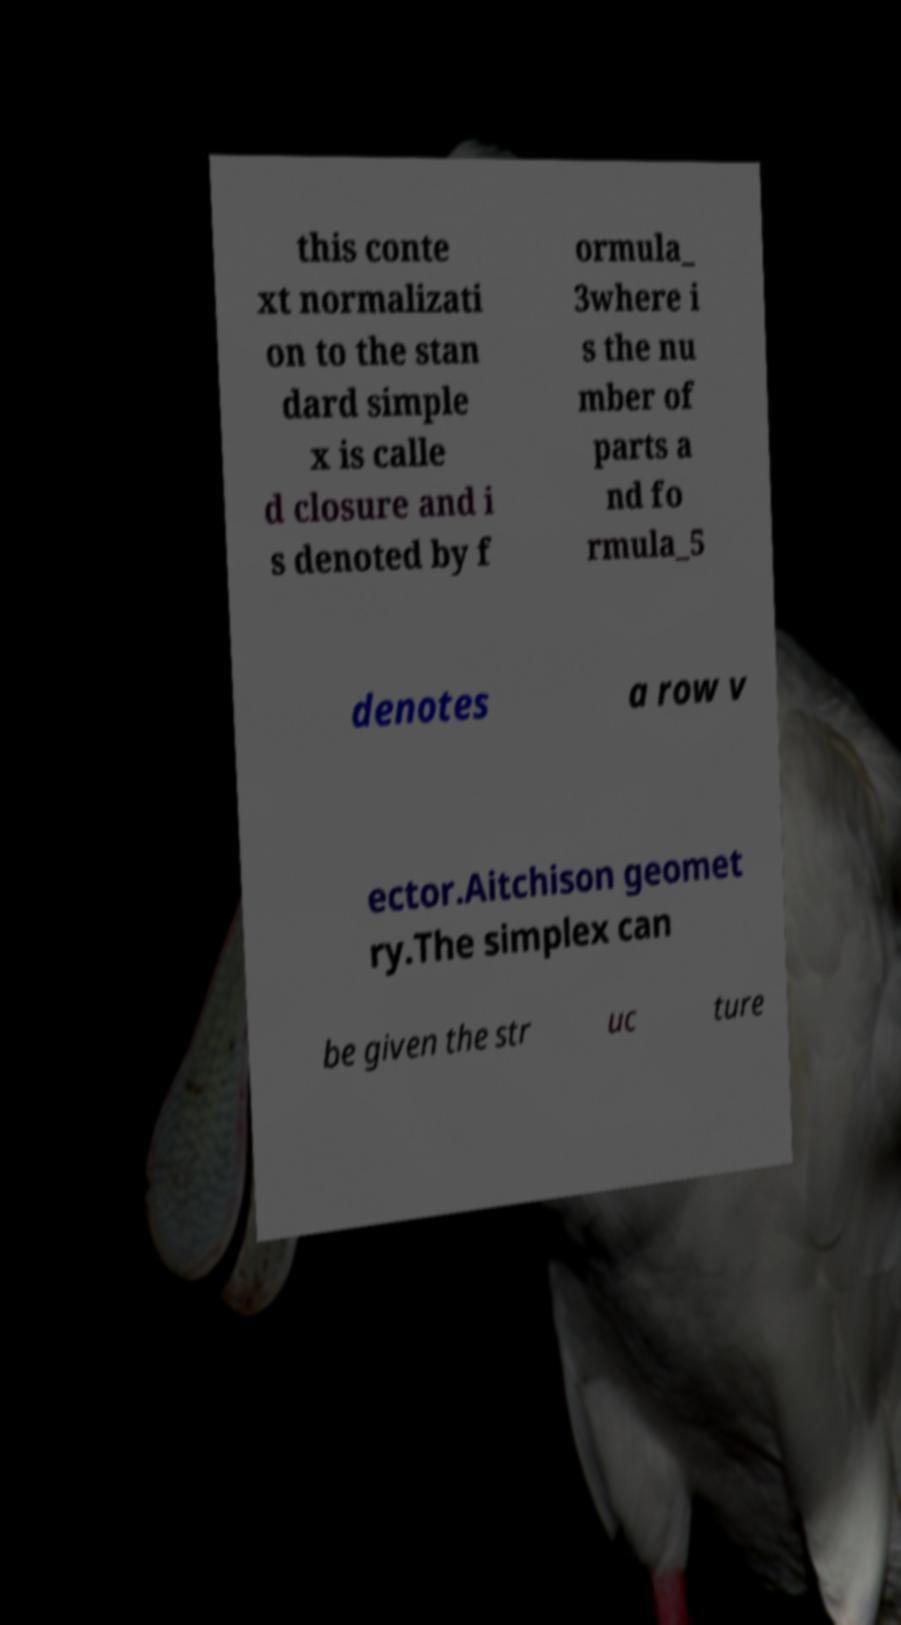Please read and relay the text visible in this image. What does it say? this conte xt normalizati on to the stan dard simple x is calle d closure and i s denoted by f ormula_ 3where i s the nu mber of parts a nd fo rmula_5 denotes a row v ector.Aitchison geomet ry.The simplex can be given the str uc ture 